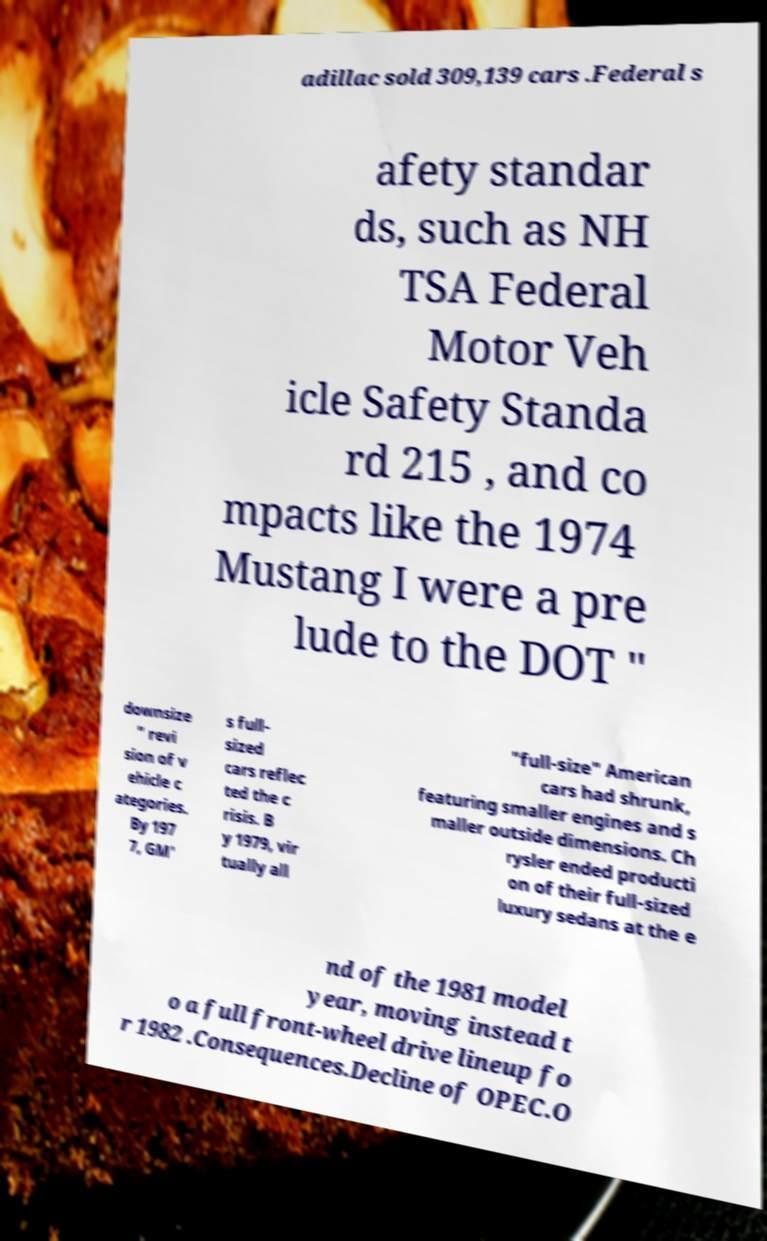I need the written content from this picture converted into text. Can you do that? adillac sold 309,139 cars .Federal s afety standar ds, such as NH TSA Federal Motor Veh icle Safety Standa rd 215 , and co mpacts like the 1974 Mustang I were a pre lude to the DOT " downsize " revi sion of v ehicle c ategories. By 197 7, GM' s full- sized cars reflec ted the c risis. B y 1979, vir tually all "full-size" American cars had shrunk, featuring smaller engines and s maller outside dimensions. Ch rysler ended producti on of their full-sized luxury sedans at the e nd of the 1981 model year, moving instead t o a full front-wheel drive lineup fo r 1982 .Consequences.Decline of OPEC.O 